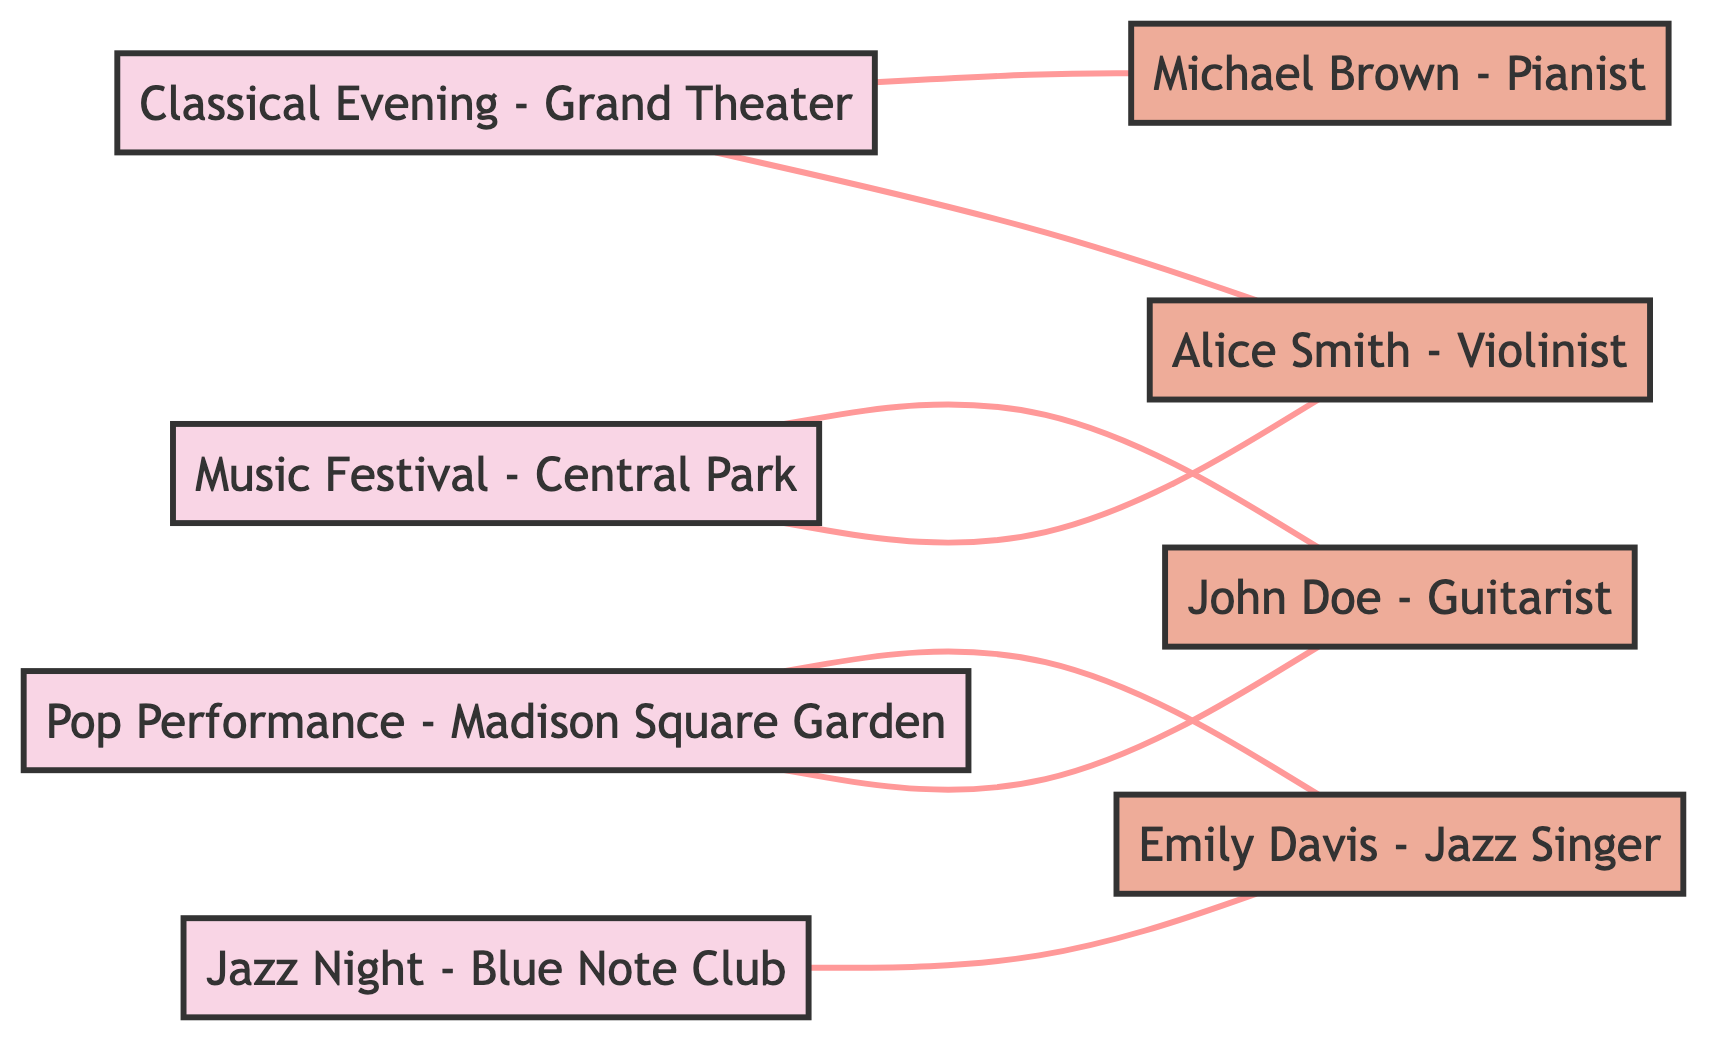What is the total number of events shown in the diagram? The diagram lists four distinct events: Music Festival - Central Park, Jazz Night - Blue Note Club, Classical Evening - Grand Theater, and Pop Performance - Madison Square Garden. Counting these gives a total of four events.
Answer: 4 Which performer is associated with the Pop Performance event? The Pop Performance - Madison Square Garden has edges connecting it to two performers: John Doe - Guitarist and Emily Davis - Jazz Singer. Thus, both performers are associated with this event.
Answer: John Doe, Emily Davis How many performers are listed in the diagram? The diagram presents a total of four distinct performers: Alice Smith - Violinist, John Doe - Guitarist, Emily Davis - Jazz Singer, and Michael Brown - Pianist, leading to a total count of four performers.
Answer: 4 Which event has the most performers associated with it? By examining the edges, Music Festival - Central Park has two performers (Alice Smith, John Doe), Jazz Night - Blue Note Club has one (Emily Davis), Classical Evening - Grand Theater has two (Alice Smith, Michael Brown), and Pop Performance - Madison Square Garden has two (John Doe, Emily Davis). Therefore, the events with the most performers tied at two are Music Festival, Classical Evening, and Pop Performance.
Answer: Music Festival, Classical Evening, Pop Performance Is there any performer who is involved in multiple events? Upon review, Alice Smith - Violinist appears in both Music Festival - Central Park and Classical Evening - Grand Theater, while John Doe - Guitarist is in both Music Festival and Pop Performance, and Emily Davis - Jazz Singer performs in both Jazz Night and Pop Performance. Thus, each of these three performers is involved in multiple events.
Answer: Yes, multiple performers How many edges connect the performers to the events? The diagram shows a total of seven edges: Music Festival to Alice Smith, Music Festival to John Doe, Jazz Night to Emily Davis, Classical Evening to Alice Smith, Classical Evening to Michael Brown, Pop Performance to John Doe, and Pop Performance to Emily Davis, making it seven edges in total.
Answer: 7 Which performer is solely associated with the Classical Evening event? The Classical Evening - Grand Theater connects to two performers: Alice Smith and Michael Brown. Since there is no performer that is solely associated with the event, the answer would be none.
Answer: None What is the relationship type portrayed in this diagram? The relationship represented in the diagram is undirected, indicating mutual connections between events and performers without a specific directional flow; therefore, all connections are bidirectional.
Answer: Undirected 